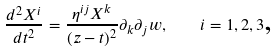Convert formula to latex. <formula><loc_0><loc_0><loc_500><loc_500>\frac { d ^ { 2 } X ^ { i } } { d t ^ { 2 } } = \frac { \eta ^ { i j } X ^ { k } } { ( z - t ) ^ { 2 } } \partial _ { k } \partial _ { j } w , \quad i = 1 , 2 , 3 \text {,}</formula> 